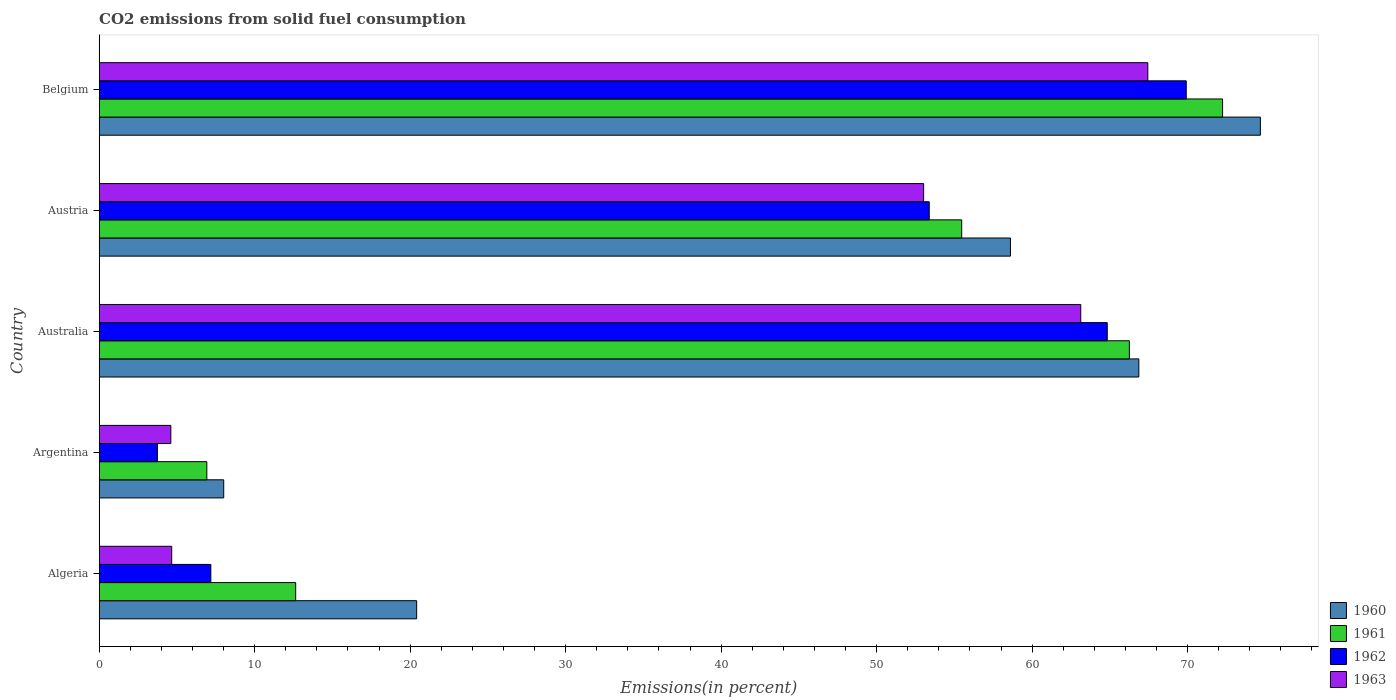How many different coloured bars are there?
Your answer should be compact. 4. How many groups of bars are there?
Your answer should be compact. 5. Are the number of bars per tick equal to the number of legend labels?
Provide a short and direct response. Yes. Are the number of bars on each tick of the Y-axis equal?
Offer a terse response. Yes. How many bars are there on the 1st tick from the top?
Ensure brevity in your answer.  4. What is the label of the 3rd group of bars from the top?
Keep it short and to the point. Australia. What is the total CO2 emitted in 1961 in Argentina?
Your answer should be very brief. 6.92. Across all countries, what is the maximum total CO2 emitted in 1960?
Your answer should be very brief. 74.68. Across all countries, what is the minimum total CO2 emitted in 1960?
Offer a terse response. 8.01. In which country was the total CO2 emitted in 1960 minimum?
Give a very brief answer. Argentina. What is the total total CO2 emitted in 1963 in the graph?
Ensure brevity in your answer.  192.86. What is the difference between the total CO2 emitted in 1961 in Australia and that in Belgium?
Offer a terse response. -5.99. What is the difference between the total CO2 emitted in 1961 in Belgium and the total CO2 emitted in 1960 in Algeria?
Give a very brief answer. 51.83. What is the average total CO2 emitted in 1961 per country?
Provide a short and direct response. 42.71. What is the difference between the total CO2 emitted in 1960 and total CO2 emitted in 1961 in Australia?
Provide a short and direct response. 0.61. In how many countries, is the total CO2 emitted in 1961 greater than 22 %?
Your answer should be very brief. 3. What is the ratio of the total CO2 emitted in 1962 in Algeria to that in Belgium?
Give a very brief answer. 0.1. Is the total CO2 emitted in 1961 in Australia less than that in Belgium?
Provide a succinct answer. Yes. What is the difference between the highest and the second highest total CO2 emitted in 1961?
Ensure brevity in your answer.  5.99. What is the difference between the highest and the lowest total CO2 emitted in 1962?
Offer a terse response. 66.17. Is the sum of the total CO2 emitted in 1960 in Algeria and Argentina greater than the maximum total CO2 emitted in 1961 across all countries?
Offer a very short reply. No. Is it the case that in every country, the sum of the total CO2 emitted in 1961 and total CO2 emitted in 1962 is greater than the total CO2 emitted in 1960?
Keep it short and to the point. No. How many bars are there?
Your answer should be very brief. 20. Are all the bars in the graph horizontal?
Provide a succinct answer. Yes. What is the difference between two consecutive major ticks on the X-axis?
Provide a succinct answer. 10. Are the values on the major ticks of X-axis written in scientific E-notation?
Make the answer very short. No. Does the graph contain any zero values?
Ensure brevity in your answer.  No. Does the graph contain grids?
Your answer should be compact. No. Where does the legend appear in the graph?
Your answer should be compact. Bottom right. How many legend labels are there?
Provide a succinct answer. 4. What is the title of the graph?
Ensure brevity in your answer.  CO2 emissions from solid fuel consumption. What is the label or title of the X-axis?
Offer a terse response. Emissions(in percent). What is the Emissions(in percent) in 1960 in Algeria?
Your answer should be compact. 20.42. What is the Emissions(in percent) of 1961 in Algeria?
Offer a very short reply. 12.64. What is the Emissions(in percent) of 1962 in Algeria?
Ensure brevity in your answer.  7.18. What is the Emissions(in percent) in 1963 in Algeria?
Make the answer very short. 4.66. What is the Emissions(in percent) in 1960 in Argentina?
Your response must be concise. 8.01. What is the Emissions(in percent) of 1961 in Argentina?
Your response must be concise. 6.92. What is the Emissions(in percent) in 1962 in Argentina?
Ensure brevity in your answer.  3.74. What is the Emissions(in percent) of 1963 in Argentina?
Ensure brevity in your answer.  4.61. What is the Emissions(in percent) in 1960 in Australia?
Keep it short and to the point. 66.86. What is the Emissions(in percent) of 1961 in Australia?
Provide a succinct answer. 66.26. What is the Emissions(in percent) in 1962 in Australia?
Your answer should be compact. 64.83. What is the Emissions(in percent) in 1963 in Australia?
Your answer should be very brief. 63.13. What is the Emissions(in percent) in 1960 in Austria?
Your response must be concise. 58.61. What is the Emissions(in percent) in 1961 in Austria?
Keep it short and to the point. 55.47. What is the Emissions(in percent) in 1962 in Austria?
Offer a very short reply. 53.39. What is the Emissions(in percent) in 1963 in Austria?
Your answer should be very brief. 53.02. What is the Emissions(in percent) in 1960 in Belgium?
Give a very brief answer. 74.68. What is the Emissions(in percent) in 1961 in Belgium?
Provide a succinct answer. 72.25. What is the Emissions(in percent) of 1962 in Belgium?
Your answer should be compact. 69.91. What is the Emissions(in percent) of 1963 in Belgium?
Give a very brief answer. 67.44. Across all countries, what is the maximum Emissions(in percent) of 1960?
Provide a succinct answer. 74.68. Across all countries, what is the maximum Emissions(in percent) of 1961?
Keep it short and to the point. 72.25. Across all countries, what is the maximum Emissions(in percent) of 1962?
Make the answer very short. 69.91. Across all countries, what is the maximum Emissions(in percent) in 1963?
Your answer should be compact. 67.44. Across all countries, what is the minimum Emissions(in percent) of 1960?
Make the answer very short. 8.01. Across all countries, what is the minimum Emissions(in percent) of 1961?
Make the answer very short. 6.92. Across all countries, what is the minimum Emissions(in percent) of 1962?
Provide a succinct answer. 3.74. Across all countries, what is the minimum Emissions(in percent) in 1963?
Ensure brevity in your answer.  4.61. What is the total Emissions(in percent) in 1960 in the graph?
Offer a terse response. 228.58. What is the total Emissions(in percent) in 1961 in the graph?
Provide a short and direct response. 213.54. What is the total Emissions(in percent) of 1962 in the graph?
Keep it short and to the point. 199.06. What is the total Emissions(in percent) in 1963 in the graph?
Provide a succinct answer. 192.86. What is the difference between the Emissions(in percent) in 1960 in Algeria and that in Argentina?
Your response must be concise. 12.41. What is the difference between the Emissions(in percent) in 1961 in Algeria and that in Argentina?
Your answer should be compact. 5.71. What is the difference between the Emissions(in percent) in 1962 in Algeria and that in Argentina?
Offer a terse response. 3.44. What is the difference between the Emissions(in percent) of 1963 in Algeria and that in Argentina?
Provide a short and direct response. 0.06. What is the difference between the Emissions(in percent) in 1960 in Algeria and that in Australia?
Offer a terse response. -46.45. What is the difference between the Emissions(in percent) in 1961 in Algeria and that in Australia?
Give a very brief answer. -53.62. What is the difference between the Emissions(in percent) in 1962 in Algeria and that in Australia?
Give a very brief answer. -57.65. What is the difference between the Emissions(in percent) in 1963 in Algeria and that in Australia?
Your answer should be very brief. -58.47. What is the difference between the Emissions(in percent) of 1960 in Algeria and that in Austria?
Your answer should be very brief. -38.19. What is the difference between the Emissions(in percent) in 1961 in Algeria and that in Austria?
Your response must be concise. -42.84. What is the difference between the Emissions(in percent) of 1962 in Algeria and that in Austria?
Keep it short and to the point. -46.21. What is the difference between the Emissions(in percent) in 1963 in Algeria and that in Austria?
Your answer should be compact. -48.36. What is the difference between the Emissions(in percent) of 1960 in Algeria and that in Belgium?
Provide a short and direct response. -54.27. What is the difference between the Emissions(in percent) in 1961 in Algeria and that in Belgium?
Offer a very short reply. -59.61. What is the difference between the Emissions(in percent) in 1962 in Algeria and that in Belgium?
Your answer should be very brief. -62.73. What is the difference between the Emissions(in percent) of 1963 in Algeria and that in Belgium?
Keep it short and to the point. -62.78. What is the difference between the Emissions(in percent) in 1960 in Argentina and that in Australia?
Keep it short and to the point. -58.86. What is the difference between the Emissions(in percent) in 1961 in Argentina and that in Australia?
Give a very brief answer. -59.34. What is the difference between the Emissions(in percent) of 1962 in Argentina and that in Australia?
Give a very brief answer. -61.09. What is the difference between the Emissions(in percent) of 1963 in Argentina and that in Australia?
Make the answer very short. -58.52. What is the difference between the Emissions(in percent) of 1960 in Argentina and that in Austria?
Offer a very short reply. -50.6. What is the difference between the Emissions(in percent) of 1961 in Argentina and that in Austria?
Offer a very short reply. -48.55. What is the difference between the Emissions(in percent) of 1962 in Argentina and that in Austria?
Give a very brief answer. -49.64. What is the difference between the Emissions(in percent) of 1963 in Argentina and that in Austria?
Offer a very short reply. -48.42. What is the difference between the Emissions(in percent) in 1960 in Argentina and that in Belgium?
Offer a very short reply. -66.67. What is the difference between the Emissions(in percent) in 1961 in Argentina and that in Belgium?
Make the answer very short. -65.33. What is the difference between the Emissions(in percent) of 1962 in Argentina and that in Belgium?
Offer a terse response. -66.17. What is the difference between the Emissions(in percent) of 1963 in Argentina and that in Belgium?
Your answer should be compact. -62.84. What is the difference between the Emissions(in percent) in 1960 in Australia and that in Austria?
Your answer should be very brief. 8.26. What is the difference between the Emissions(in percent) of 1961 in Australia and that in Austria?
Your answer should be compact. 10.78. What is the difference between the Emissions(in percent) in 1962 in Australia and that in Austria?
Your answer should be compact. 11.45. What is the difference between the Emissions(in percent) of 1963 in Australia and that in Austria?
Your answer should be very brief. 10.11. What is the difference between the Emissions(in percent) of 1960 in Australia and that in Belgium?
Your answer should be compact. -7.82. What is the difference between the Emissions(in percent) in 1961 in Australia and that in Belgium?
Your answer should be very brief. -5.99. What is the difference between the Emissions(in percent) in 1962 in Australia and that in Belgium?
Your answer should be compact. -5.08. What is the difference between the Emissions(in percent) of 1963 in Australia and that in Belgium?
Provide a short and direct response. -4.31. What is the difference between the Emissions(in percent) of 1960 in Austria and that in Belgium?
Ensure brevity in your answer.  -16.07. What is the difference between the Emissions(in percent) in 1961 in Austria and that in Belgium?
Keep it short and to the point. -16.78. What is the difference between the Emissions(in percent) in 1962 in Austria and that in Belgium?
Give a very brief answer. -16.53. What is the difference between the Emissions(in percent) in 1963 in Austria and that in Belgium?
Make the answer very short. -14.42. What is the difference between the Emissions(in percent) in 1960 in Algeria and the Emissions(in percent) in 1961 in Argentina?
Your answer should be compact. 13.5. What is the difference between the Emissions(in percent) of 1960 in Algeria and the Emissions(in percent) of 1962 in Argentina?
Keep it short and to the point. 16.67. What is the difference between the Emissions(in percent) of 1960 in Algeria and the Emissions(in percent) of 1963 in Argentina?
Offer a very short reply. 15.81. What is the difference between the Emissions(in percent) of 1961 in Algeria and the Emissions(in percent) of 1962 in Argentina?
Keep it short and to the point. 8.89. What is the difference between the Emissions(in percent) of 1961 in Algeria and the Emissions(in percent) of 1963 in Argentina?
Provide a short and direct response. 8.03. What is the difference between the Emissions(in percent) of 1962 in Algeria and the Emissions(in percent) of 1963 in Argentina?
Your response must be concise. 2.57. What is the difference between the Emissions(in percent) in 1960 in Algeria and the Emissions(in percent) in 1961 in Australia?
Offer a terse response. -45.84. What is the difference between the Emissions(in percent) in 1960 in Algeria and the Emissions(in percent) in 1962 in Australia?
Make the answer very short. -44.42. What is the difference between the Emissions(in percent) of 1960 in Algeria and the Emissions(in percent) of 1963 in Australia?
Your answer should be compact. -42.71. What is the difference between the Emissions(in percent) of 1961 in Algeria and the Emissions(in percent) of 1962 in Australia?
Offer a terse response. -52.2. What is the difference between the Emissions(in percent) of 1961 in Algeria and the Emissions(in percent) of 1963 in Australia?
Your answer should be compact. -50.49. What is the difference between the Emissions(in percent) of 1962 in Algeria and the Emissions(in percent) of 1963 in Australia?
Give a very brief answer. -55.95. What is the difference between the Emissions(in percent) of 1960 in Algeria and the Emissions(in percent) of 1961 in Austria?
Your answer should be very brief. -35.06. What is the difference between the Emissions(in percent) of 1960 in Algeria and the Emissions(in percent) of 1962 in Austria?
Provide a short and direct response. -32.97. What is the difference between the Emissions(in percent) in 1960 in Algeria and the Emissions(in percent) in 1963 in Austria?
Give a very brief answer. -32.61. What is the difference between the Emissions(in percent) in 1961 in Algeria and the Emissions(in percent) in 1962 in Austria?
Give a very brief answer. -40.75. What is the difference between the Emissions(in percent) in 1961 in Algeria and the Emissions(in percent) in 1963 in Austria?
Keep it short and to the point. -40.39. What is the difference between the Emissions(in percent) of 1962 in Algeria and the Emissions(in percent) of 1963 in Austria?
Keep it short and to the point. -45.84. What is the difference between the Emissions(in percent) of 1960 in Algeria and the Emissions(in percent) of 1961 in Belgium?
Make the answer very short. -51.83. What is the difference between the Emissions(in percent) in 1960 in Algeria and the Emissions(in percent) in 1962 in Belgium?
Keep it short and to the point. -49.5. What is the difference between the Emissions(in percent) of 1960 in Algeria and the Emissions(in percent) of 1963 in Belgium?
Offer a terse response. -47.03. What is the difference between the Emissions(in percent) in 1961 in Algeria and the Emissions(in percent) in 1962 in Belgium?
Keep it short and to the point. -57.28. What is the difference between the Emissions(in percent) of 1961 in Algeria and the Emissions(in percent) of 1963 in Belgium?
Provide a succinct answer. -54.81. What is the difference between the Emissions(in percent) of 1962 in Algeria and the Emissions(in percent) of 1963 in Belgium?
Make the answer very short. -60.26. What is the difference between the Emissions(in percent) of 1960 in Argentina and the Emissions(in percent) of 1961 in Australia?
Offer a terse response. -58.25. What is the difference between the Emissions(in percent) in 1960 in Argentina and the Emissions(in percent) in 1962 in Australia?
Offer a terse response. -56.83. What is the difference between the Emissions(in percent) of 1960 in Argentina and the Emissions(in percent) of 1963 in Australia?
Give a very brief answer. -55.12. What is the difference between the Emissions(in percent) of 1961 in Argentina and the Emissions(in percent) of 1962 in Australia?
Give a very brief answer. -57.91. What is the difference between the Emissions(in percent) in 1961 in Argentina and the Emissions(in percent) in 1963 in Australia?
Provide a short and direct response. -56.21. What is the difference between the Emissions(in percent) in 1962 in Argentina and the Emissions(in percent) in 1963 in Australia?
Provide a short and direct response. -59.39. What is the difference between the Emissions(in percent) of 1960 in Argentina and the Emissions(in percent) of 1961 in Austria?
Your response must be concise. -47.46. What is the difference between the Emissions(in percent) of 1960 in Argentina and the Emissions(in percent) of 1962 in Austria?
Give a very brief answer. -45.38. What is the difference between the Emissions(in percent) in 1960 in Argentina and the Emissions(in percent) in 1963 in Austria?
Provide a succinct answer. -45.02. What is the difference between the Emissions(in percent) of 1961 in Argentina and the Emissions(in percent) of 1962 in Austria?
Your answer should be very brief. -46.46. What is the difference between the Emissions(in percent) of 1961 in Argentina and the Emissions(in percent) of 1963 in Austria?
Keep it short and to the point. -46.1. What is the difference between the Emissions(in percent) of 1962 in Argentina and the Emissions(in percent) of 1963 in Austria?
Your answer should be compact. -49.28. What is the difference between the Emissions(in percent) in 1960 in Argentina and the Emissions(in percent) in 1961 in Belgium?
Ensure brevity in your answer.  -64.24. What is the difference between the Emissions(in percent) in 1960 in Argentina and the Emissions(in percent) in 1962 in Belgium?
Give a very brief answer. -61.91. What is the difference between the Emissions(in percent) in 1960 in Argentina and the Emissions(in percent) in 1963 in Belgium?
Your answer should be compact. -59.43. What is the difference between the Emissions(in percent) of 1961 in Argentina and the Emissions(in percent) of 1962 in Belgium?
Provide a succinct answer. -62.99. What is the difference between the Emissions(in percent) of 1961 in Argentina and the Emissions(in percent) of 1963 in Belgium?
Your answer should be very brief. -60.52. What is the difference between the Emissions(in percent) of 1962 in Argentina and the Emissions(in percent) of 1963 in Belgium?
Keep it short and to the point. -63.7. What is the difference between the Emissions(in percent) in 1960 in Australia and the Emissions(in percent) in 1961 in Austria?
Your response must be concise. 11.39. What is the difference between the Emissions(in percent) in 1960 in Australia and the Emissions(in percent) in 1962 in Austria?
Offer a terse response. 13.48. What is the difference between the Emissions(in percent) in 1960 in Australia and the Emissions(in percent) in 1963 in Austria?
Provide a succinct answer. 13.84. What is the difference between the Emissions(in percent) of 1961 in Australia and the Emissions(in percent) of 1962 in Austria?
Offer a very short reply. 12.87. What is the difference between the Emissions(in percent) of 1961 in Australia and the Emissions(in percent) of 1963 in Austria?
Your answer should be very brief. 13.23. What is the difference between the Emissions(in percent) of 1962 in Australia and the Emissions(in percent) of 1963 in Austria?
Provide a short and direct response. 11.81. What is the difference between the Emissions(in percent) in 1960 in Australia and the Emissions(in percent) in 1961 in Belgium?
Make the answer very short. -5.39. What is the difference between the Emissions(in percent) of 1960 in Australia and the Emissions(in percent) of 1962 in Belgium?
Give a very brief answer. -3.05. What is the difference between the Emissions(in percent) in 1960 in Australia and the Emissions(in percent) in 1963 in Belgium?
Make the answer very short. -0.58. What is the difference between the Emissions(in percent) in 1961 in Australia and the Emissions(in percent) in 1962 in Belgium?
Offer a terse response. -3.66. What is the difference between the Emissions(in percent) in 1961 in Australia and the Emissions(in percent) in 1963 in Belgium?
Make the answer very short. -1.19. What is the difference between the Emissions(in percent) in 1962 in Australia and the Emissions(in percent) in 1963 in Belgium?
Make the answer very short. -2.61. What is the difference between the Emissions(in percent) in 1960 in Austria and the Emissions(in percent) in 1961 in Belgium?
Your response must be concise. -13.64. What is the difference between the Emissions(in percent) of 1960 in Austria and the Emissions(in percent) of 1962 in Belgium?
Ensure brevity in your answer.  -11.31. What is the difference between the Emissions(in percent) in 1960 in Austria and the Emissions(in percent) in 1963 in Belgium?
Provide a short and direct response. -8.83. What is the difference between the Emissions(in percent) of 1961 in Austria and the Emissions(in percent) of 1962 in Belgium?
Provide a succinct answer. -14.44. What is the difference between the Emissions(in percent) in 1961 in Austria and the Emissions(in percent) in 1963 in Belgium?
Make the answer very short. -11.97. What is the difference between the Emissions(in percent) of 1962 in Austria and the Emissions(in percent) of 1963 in Belgium?
Your response must be concise. -14.06. What is the average Emissions(in percent) of 1960 per country?
Your response must be concise. 45.72. What is the average Emissions(in percent) in 1961 per country?
Your answer should be very brief. 42.71. What is the average Emissions(in percent) of 1962 per country?
Your response must be concise. 39.81. What is the average Emissions(in percent) of 1963 per country?
Your response must be concise. 38.57. What is the difference between the Emissions(in percent) of 1960 and Emissions(in percent) of 1961 in Algeria?
Keep it short and to the point. 7.78. What is the difference between the Emissions(in percent) in 1960 and Emissions(in percent) in 1962 in Algeria?
Offer a very short reply. 13.24. What is the difference between the Emissions(in percent) of 1960 and Emissions(in percent) of 1963 in Algeria?
Your answer should be compact. 15.75. What is the difference between the Emissions(in percent) in 1961 and Emissions(in percent) in 1962 in Algeria?
Offer a terse response. 5.46. What is the difference between the Emissions(in percent) of 1961 and Emissions(in percent) of 1963 in Algeria?
Keep it short and to the point. 7.97. What is the difference between the Emissions(in percent) in 1962 and Emissions(in percent) in 1963 in Algeria?
Make the answer very short. 2.52. What is the difference between the Emissions(in percent) in 1960 and Emissions(in percent) in 1961 in Argentina?
Offer a terse response. 1.09. What is the difference between the Emissions(in percent) of 1960 and Emissions(in percent) of 1962 in Argentina?
Offer a terse response. 4.27. What is the difference between the Emissions(in percent) in 1960 and Emissions(in percent) in 1963 in Argentina?
Your response must be concise. 3.4. What is the difference between the Emissions(in percent) in 1961 and Emissions(in percent) in 1962 in Argentina?
Your answer should be compact. 3.18. What is the difference between the Emissions(in percent) of 1961 and Emissions(in percent) of 1963 in Argentina?
Keep it short and to the point. 2.32. What is the difference between the Emissions(in percent) in 1962 and Emissions(in percent) in 1963 in Argentina?
Keep it short and to the point. -0.86. What is the difference between the Emissions(in percent) of 1960 and Emissions(in percent) of 1961 in Australia?
Provide a succinct answer. 0.61. What is the difference between the Emissions(in percent) in 1960 and Emissions(in percent) in 1962 in Australia?
Offer a very short reply. 2.03. What is the difference between the Emissions(in percent) in 1960 and Emissions(in percent) in 1963 in Australia?
Make the answer very short. 3.73. What is the difference between the Emissions(in percent) of 1961 and Emissions(in percent) of 1962 in Australia?
Offer a very short reply. 1.42. What is the difference between the Emissions(in percent) of 1961 and Emissions(in percent) of 1963 in Australia?
Make the answer very short. 3.13. What is the difference between the Emissions(in percent) in 1962 and Emissions(in percent) in 1963 in Australia?
Offer a very short reply. 1.7. What is the difference between the Emissions(in percent) of 1960 and Emissions(in percent) of 1961 in Austria?
Your answer should be very brief. 3.14. What is the difference between the Emissions(in percent) of 1960 and Emissions(in percent) of 1962 in Austria?
Offer a terse response. 5.22. What is the difference between the Emissions(in percent) in 1960 and Emissions(in percent) in 1963 in Austria?
Offer a very short reply. 5.58. What is the difference between the Emissions(in percent) in 1961 and Emissions(in percent) in 1962 in Austria?
Your answer should be compact. 2.09. What is the difference between the Emissions(in percent) of 1961 and Emissions(in percent) of 1963 in Austria?
Provide a short and direct response. 2.45. What is the difference between the Emissions(in percent) of 1962 and Emissions(in percent) of 1963 in Austria?
Ensure brevity in your answer.  0.36. What is the difference between the Emissions(in percent) in 1960 and Emissions(in percent) in 1961 in Belgium?
Provide a short and direct response. 2.43. What is the difference between the Emissions(in percent) of 1960 and Emissions(in percent) of 1962 in Belgium?
Provide a succinct answer. 4.77. What is the difference between the Emissions(in percent) in 1960 and Emissions(in percent) in 1963 in Belgium?
Offer a terse response. 7.24. What is the difference between the Emissions(in percent) in 1961 and Emissions(in percent) in 1962 in Belgium?
Offer a very short reply. 2.34. What is the difference between the Emissions(in percent) in 1961 and Emissions(in percent) in 1963 in Belgium?
Your response must be concise. 4.81. What is the difference between the Emissions(in percent) in 1962 and Emissions(in percent) in 1963 in Belgium?
Offer a terse response. 2.47. What is the ratio of the Emissions(in percent) in 1960 in Algeria to that in Argentina?
Ensure brevity in your answer.  2.55. What is the ratio of the Emissions(in percent) of 1961 in Algeria to that in Argentina?
Ensure brevity in your answer.  1.83. What is the ratio of the Emissions(in percent) of 1962 in Algeria to that in Argentina?
Provide a succinct answer. 1.92. What is the ratio of the Emissions(in percent) of 1963 in Algeria to that in Argentina?
Your answer should be compact. 1.01. What is the ratio of the Emissions(in percent) of 1960 in Algeria to that in Australia?
Ensure brevity in your answer.  0.31. What is the ratio of the Emissions(in percent) in 1961 in Algeria to that in Australia?
Your answer should be compact. 0.19. What is the ratio of the Emissions(in percent) of 1962 in Algeria to that in Australia?
Make the answer very short. 0.11. What is the ratio of the Emissions(in percent) of 1963 in Algeria to that in Australia?
Your answer should be compact. 0.07. What is the ratio of the Emissions(in percent) in 1960 in Algeria to that in Austria?
Your response must be concise. 0.35. What is the ratio of the Emissions(in percent) of 1961 in Algeria to that in Austria?
Your response must be concise. 0.23. What is the ratio of the Emissions(in percent) in 1962 in Algeria to that in Austria?
Make the answer very short. 0.13. What is the ratio of the Emissions(in percent) in 1963 in Algeria to that in Austria?
Make the answer very short. 0.09. What is the ratio of the Emissions(in percent) in 1960 in Algeria to that in Belgium?
Ensure brevity in your answer.  0.27. What is the ratio of the Emissions(in percent) of 1961 in Algeria to that in Belgium?
Give a very brief answer. 0.17. What is the ratio of the Emissions(in percent) of 1962 in Algeria to that in Belgium?
Offer a terse response. 0.1. What is the ratio of the Emissions(in percent) in 1963 in Algeria to that in Belgium?
Make the answer very short. 0.07. What is the ratio of the Emissions(in percent) of 1960 in Argentina to that in Australia?
Offer a very short reply. 0.12. What is the ratio of the Emissions(in percent) of 1961 in Argentina to that in Australia?
Provide a succinct answer. 0.1. What is the ratio of the Emissions(in percent) of 1962 in Argentina to that in Australia?
Offer a terse response. 0.06. What is the ratio of the Emissions(in percent) of 1963 in Argentina to that in Australia?
Keep it short and to the point. 0.07. What is the ratio of the Emissions(in percent) of 1960 in Argentina to that in Austria?
Provide a short and direct response. 0.14. What is the ratio of the Emissions(in percent) of 1961 in Argentina to that in Austria?
Your response must be concise. 0.12. What is the ratio of the Emissions(in percent) in 1962 in Argentina to that in Austria?
Make the answer very short. 0.07. What is the ratio of the Emissions(in percent) of 1963 in Argentina to that in Austria?
Ensure brevity in your answer.  0.09. What is the ratio of the Emissions(in percent) in 1960 in Argentina to that in Belgium?
Your answer should be compact. 0.11. What is the ratio of the Emissions(in percent) in 1961 in Argentina to that in Belgium?
Your answer should be compact. 0.1. What is the ratio of the Emissions(in percent) of 1962 in Argentina to that in Belgium?
Keep it short and to the point. 0.05. What is the ratio of the Emissions(in percent) in 1963 in Argentina to that in Belgium?
Make the answer very short. 0.07. What is the ratio of the Emissions(in percent) of 1960 in Australia to that in Austria?
Ensure brevity in your answer.  1.14. What is the ratio of the Emissions(in percent) in 1961 in Australia to that in Austria?
Your response must be concise. 1.19. What is the ratio of the Emissions(in percent) in 1962 in Australia to that in Austria?
Provide a succinct answer. 1.21. What is the ratio of the Emissions(in percent) in 1963 in Australia to that in Austria?
Provide a succinct answer. 1.19. What is the ratio of the Emissions(in percent) of 1960 in Australia to that in Belgium?
Your answer should be very brief. 0.9. What is the ratio of the Emissions(in percent) in 1961 in Australia to that in Belgium?
Offer a very short reply. 0.92. What is the ratio of the Emissions(in percent) of 1962 in Australia to that in Belgium?
Make the answer very short. 0.93. What is the ratio of the Emissions(in percent) of 1963 in Australia to that in Belgium?
Ensure brevity in your answer.  0.94. What is the ratio of the Emissions(in percent) in 1960 in Austria to that in Belgium?
Give a very brief answer. 0.78. What is the ratio of the Emissions(in percent) in 1961 in Austria to that in Belgium?
Ensure brevity in your answer.  0.77. What is the ratio of the Emissions(in percent) in 1962 in Austria to that in Belgium?
Offer a very short reply. 0.76. What is the ratio of the Emissions(in percent) of 1963 in Austria to that in Belgium?
Your answer should be very brief. 0.79. What is the difference between the highest and the second highest Emissions(in percent) of 1960?
Your response must be concise. 7.82. What is the difference between the highest and the second highest Emissions(in percent) in 1961?
Offer a terse response. 5.99. What is the difference between the highest and the second highest Emissions(in percent) of 1962?
Offer a very short reply. 5.08. What is the difference between the highest and the second highest Emissions(in percent) in 1963?
Offer a terse response. 4.31. What is the difference between the highest and the lowest Emissions(in percent) in 1960?
Your response must be concise. 66.67. What is the difference between the highest and the lowest Emissions(in percent) in 1961?
Your answer should be compact. 65.33. What is the difference between the highest and the lowest Emissions(in percent) in 1962?
Offer a very short reply. 66.17. What is the difference between the highest and the lowest Emissions(in percent) of 1963?
Your answer should be very brief. 62.84. 